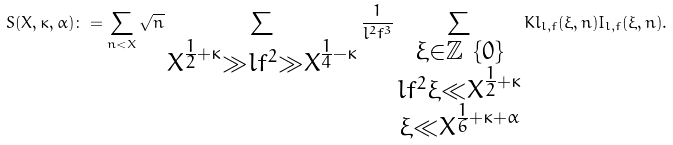Convert formula to latex. <formula><loc_0><loc_0><loc_500><loc_500>S ( X , \kappa , \alpha ) \colon = \sum _ { n < X } \sqrt { n } \sum _ { \substack { X ^ { \frac { 1 } { 2 } + \kappa } \gg l f ^ { 2 } \gg X ^ { \frac { 1 } { 4 } - \kappa } } } \frac { 1 } { l ^ { 2 } f ^ { 3 } } \sum _ { \substack { \xi \in \mathbb { Z } \ \{ 0 \} \\ l f ^ { 2 } \xi \ll X ^ { \frac { 1 } { 2 } + \kappa } \\ \xi \ll X ^ { \frac { 1 } { 6 } + \kappa + \alpha } } } K l _ { l , f } ( \xi , n ) I _ { l , f } ( \xi , n ) .</formula> 